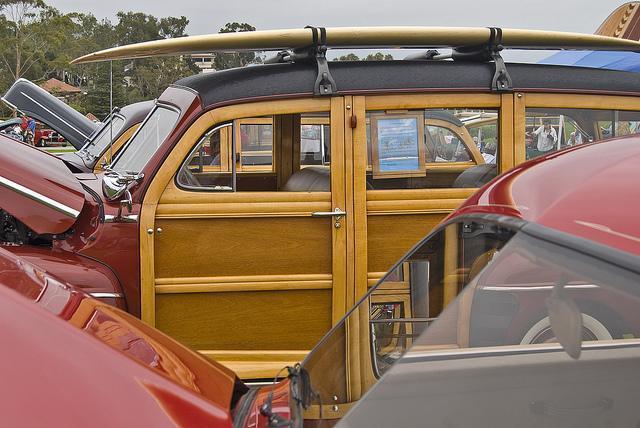How many surfboards are there?
Give a very brief answer. 1. How many cars are there?
Give a very brief answer. 4. How many horses are visible?
Give a very brief answer. 0. 